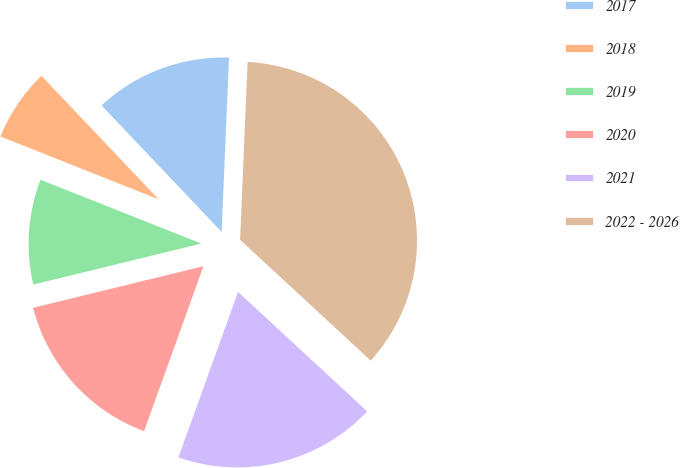Convert chart. <chart><loc_0><loc_0><loc_500><loc_500><pie_chart><fcel>2017<fcel>2018<fcel>2019<fcel>2020<fcel>2021<fcel>2022 - 2026<nl><fcel>12.76%<fcel>6.9%<fcel>9.83%<fcel>15.69%<fcel>18.62%<fcel>36.21%<nl></chart> 